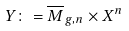<formula> <loc_0><loc_0><loc_500><loc_500>Y \colon = \overline { M } _ { g , n } \times X ^ { n }</formula> 